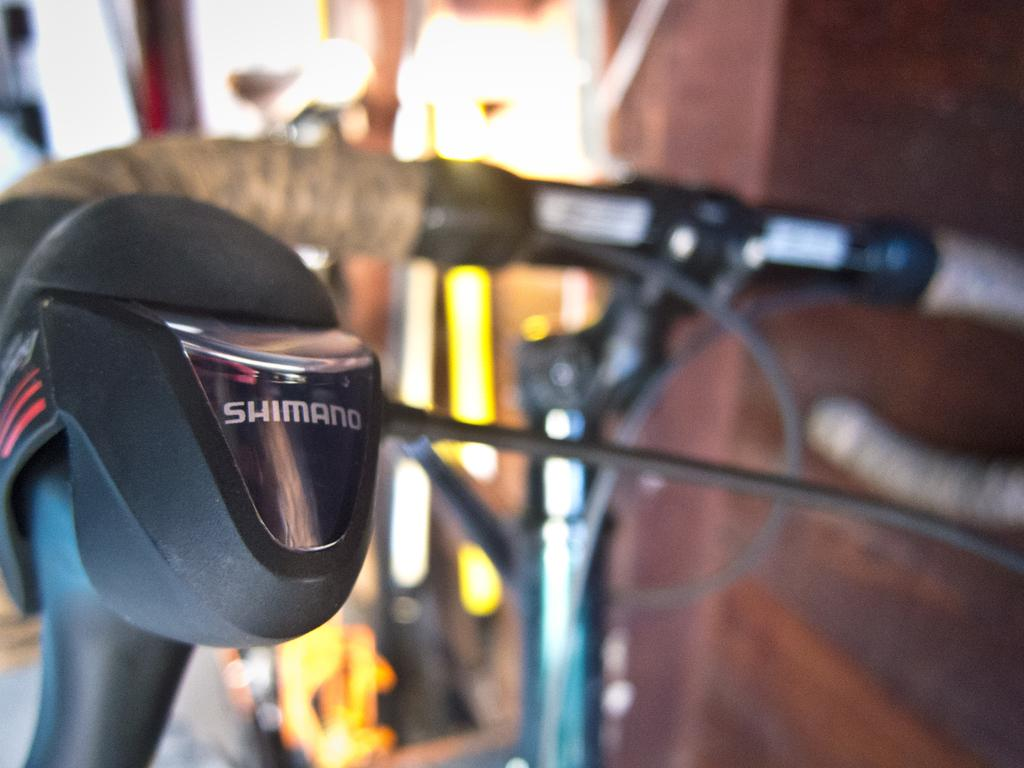What can be seen attached to the cycle handle in the image? The cycle handle has wires attached to it in the image. What type of protective gear is present in the image? There is a black helmet in the image. Where is the helmet located in relation to the cycle handle? The helmet is near the cycle handle in the image. What is the location of the cycle handle in the image? The cycle handle is placed near a wall in the image. What type of scarf is being used to pull the cart in the image? There is no scarf or cart present in the image; it only features a cycle handle with wires, a helmet, and a wall. 